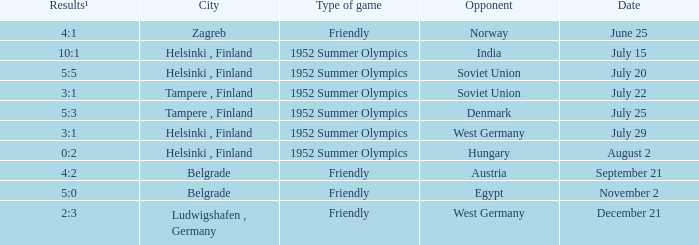What Type of game has a Results¹ of 10:1? 1952 Summer Olympics. 